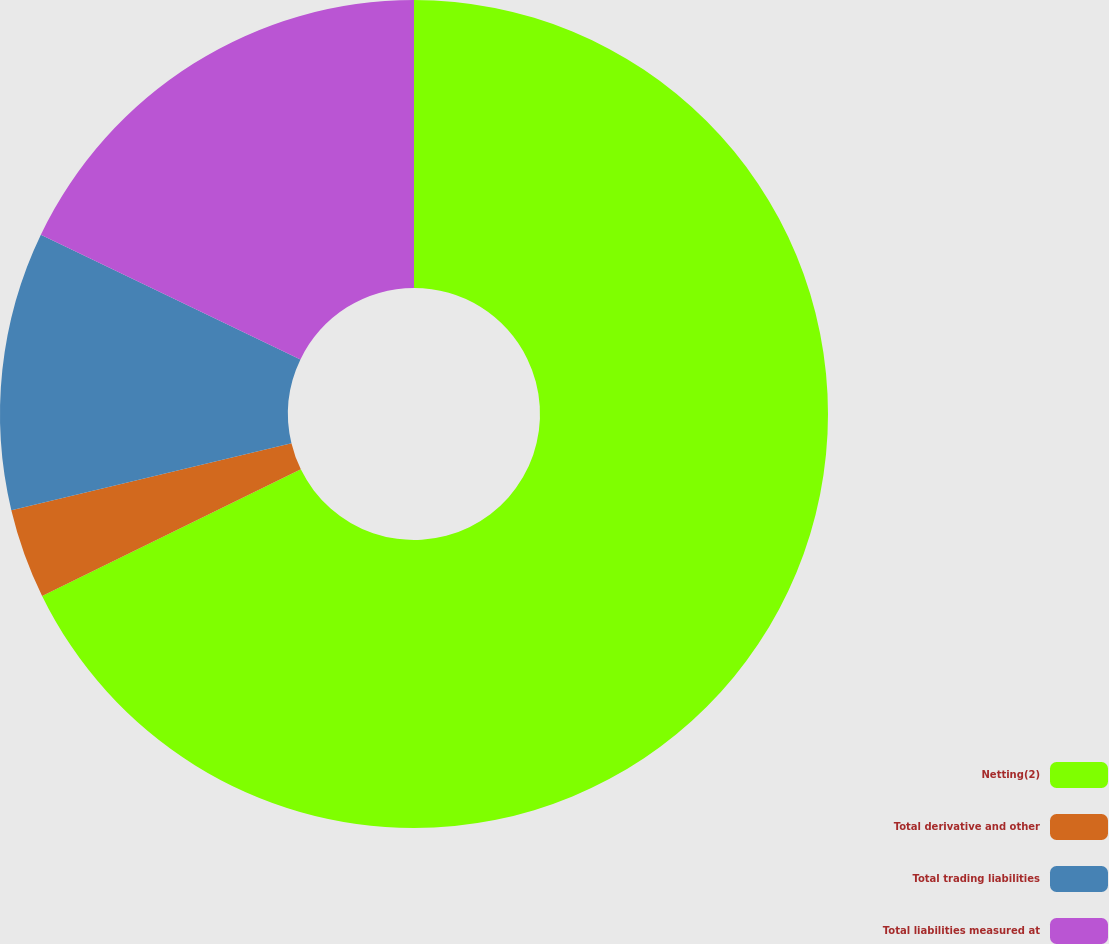<chart> <loc_0><loc_0><loc_500><loc_500><pie_chart><fcel>Netting(2)<fcel>Total derivative and other<fcel>Total trading liabilities<fcel>Total liabilities measured at<nl><fcel>67.76%<fcel>3.51%<fcel>10.86%<fcel>17.87%<nl></chart> 